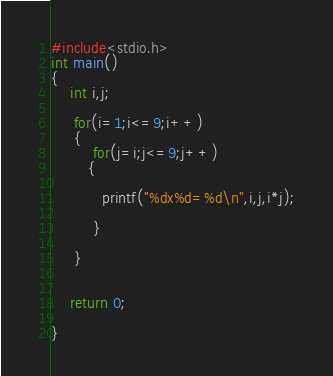<code> <loc_0><loc_0><loc_500><loc_500><_C_>#include<stdio.h>
int main()
{
    int i,j;

     for(i=1;i<=9;i++)
     {
         for(j=i;j<=9;j++)
        {

           printf("%dx%d=%d\n",i,j,i*j);

         }

     }


    return 0;

}</code> 